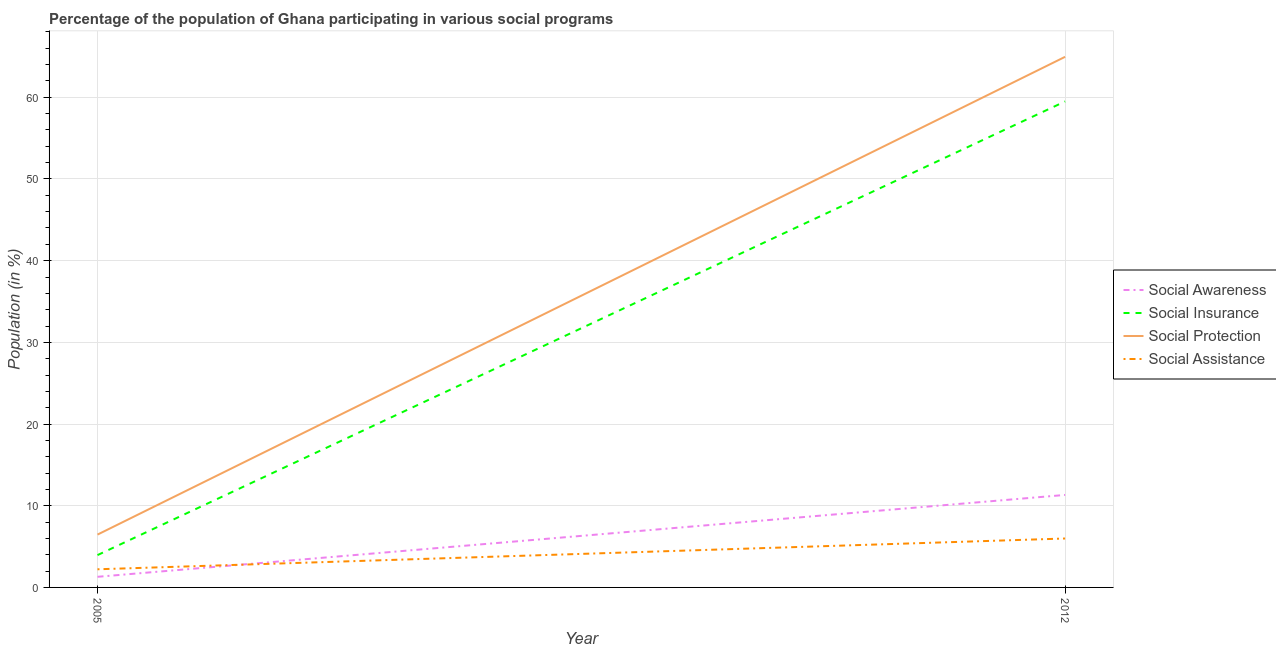How many different coloured lines are there?
Give a very brief answer. 4. Is the number of lines equal to the number of legend labels?
Offer a very short reply. Yes. What is the participation of population in social assistance programs in 2012?
Keep it short and to the point. 5.99. Across all years, what is the maximum participation of population in social protection programs?
Keep it short and to the point. 64.95. Across all years, what is the minimum participation of population in social awareness programs?
Offer a very short reply. 1.3. What is the total participation of population in social protection programs in the graph?
Offer a very short reply. 71.42. What is the difference between the participation of population in social assistance programs in 2005 and that in 2012?
Offer a very short reply. -3.77. What is the difference between the participation of population in social insurance programs in 2012 and the participation of population in social assistance programs in 2005?
Your response must be concise. 57.27. What is the average participation of population in social assistance programs per year?
Keep it short and to the point. 4.1. In the year 2005, what is the difference between the participation of population in social insurance programs and participation of population in social awareness programs?
Ensure brevity in your answer.  2.66. What is the ratio of the participation of population in social awareness programs in 2005 to that in 2012?
Provide a short and direct response. 0.11. Is the participation of population in social insurance programs in 2005 less than that in 2012?
Make the answer very short. Yes. Does the participation of population in social insurance programs monotonically increase over the years?
Ensure brevity in your answer.  Yes. What is the difference between two consecutive major ticks on the Y-axis?
Keep it short and to the point. 10. Does the graph contain any zero values?
Provide a short and direct response. No. Where does the legend appear in the graph?
Offer a very short reply. Center right. How are the legend labels stacked?
Ensure brevity in your answer.  Vertical. What is the title of the graph?
Your answer should be compact. Percentage of the population of Ghana participating in various social programs . Does "Austria" appear as one of the legend labels in the graph?
Ensure brevity in your answer.  No. What is the label or title of the Y-axis?
Keep it short and to the point. Population (in %). What is the Population (in %) of Social Awareness in 2005?
Offer a terse response. 1.3. What is the Population (in %) of Social Insurance in 2005?
Your response must be concise. 3.96. What is the Population (in %) in Social Protection in 2005?
Your answer should be compact. 6.47. What is the Population (in %) in Social Assistance in 2005?
Your answer should be compact. 2.22. What is the Population (in %) in Social Awareness in 2012?
Offer a terse response. 11.32. What is the Population (in %) in Social Insurance in 2012?
Your answer should be compact. 59.49. What is the Population (in %) in Social Protection in 2012?
Give a very brief answer. 64.95. What is the Population (in %) in Social Assistance in 2012?
Provide a short and direct response. 5.99. Across all years, what is the maximum Population (in %) of Social Awareness?
Offer a very short reply. 11.32. Across all years, what is the maximum Population (in %) in Social Insurance?
Your response must be concise. 59.49. Across all years, what is the maximum Population (in %) of Social Protection?
Offer a terse response. 64.95. Across all years, what is the maximum Population (in %) in Social Assistance?
Offer a very short reply. 5.99. Across all years, what is the minimum Population (in %) in Social Awareness?
Provide a short and direct response. 1.3. Across all years, what is the minimum Population (in %) in Social Insurance?
Keep it short and to the point. 3.96. Across all years, what is the minimum Population (in %) of Social Protection?
Your answer should be very brief. 6.47. Across all years, what is the minimum Population (in %) in Social Assistance?
Provide a succinct answer. 2.22. What is the total Population (in %) in Social Awareness in the graph?
Offer a very short reply. 12.62. What is the total Population (in %) of Social Insurance in the graph?
Your response must be concise. 63.45. What is the total Population (in %) of Social Protection in the graph?
Your answer should be compact. 71.42. What is the total Population (in %) of Social Assistance in the graph?
Your answer should be very brief. 8.21. What is the difference between the Population (in %) in Social Awareness in 2005 and that in 2012?
Give a very brief answer. -10.02. What is the difference between the Population (in %) in Social Insurance in 2005 and that in 2012?
Make the answer very short. -55.53. What is the difference between the Population (in %) in Social Protection in 2005 and that in 2012?
Ensure brevity in your answer.  -58.48. What is the difference between the Population (in %) of Social Assistance in 2005 and that in 2012?
Give a very brief answer. -3.77. What is the difference between the Population (in %) in Social Awareness in 2005 and the Population (in %) in Social Insurance in 2012?
Your response must be concise. -58.19. What is the difference between the Population (in %) in Social Awareness in 2005 and the Population (in %) in Social Protection in 2012?
Your answer should be very brief. -63.65. What is the difference between the Population (in %) in Social Awareness in 2005 and the Population (in %) in Social Assistance in 2012?
Offer a terse response. -4.69. What is the difference between the Population (in %) of Social Insurance in 2005 and the Population (in %) of Social Protection in 2012?
Offer a terse response. -61. What is the difference between the Population (in %) of Social Insurance in 2005 and the Population (in %) of Social Assistance in 2012?
Make the answer very short. -2.03. What is the difference between the Population (in %) of Social Protection in 2005 and the Population (in %) of Social Assistance in 2012?
Offer a terse response. 0.48. What is the average Population (in %) in Social Awareness per year?
Offer a terse response. 6.31. What is the average Population (in %) in Social Insurance per year?
Your answer should be compact. 31.72. What is the average Population (in %) in Social Protection per year?
Make the answer very short. 35.71. What is the average Population (in %) of Social Assistance per year?
Your answer should be very brief. 4.1. In the year 2005, what is the difference between the Population (in %) in Social Awareness and Population (in %) in Social Insurance?
Make the answer very short. -2.66. In the year 2005, what is the difference between the Population (in %) of Social Awareness and Population (in %) of Social Protection?
Provide a succinct answer. -5.17. In the year 2005, what is the difference between the Population (in %) of Social Awareness and Population (in %) of Social Assistance?
Offer a very short reply. -0.92. In the year 2005, what is the difference between the Population (in %) of Social Insurance and Population (in %) of Social Protection?
Provide a short and direct response. -2.51. In the year 2005, what is the difference between the Population (in %) in Social Insurance and Population (in %) in Social Assistance?
Give a very brief answer. 1.74. In the year 2005, what is the difference between the Population (in %) in Social Protection and Population (in %) in Social Assistance?
Your answer should be compact. 4.25. In the year 2012, what is the difference between the Population (in %) of Social Awareness and Population (in %) of Social Insurance?
Your answer should be compact. -48.17. In the year 2012, what is the difference between the Population (in %) in Social Awareness and Population (in %) in Social Protection?
Ensure brevity in your answer.  -53.63. In the year 2012, what is the difference between the Population (in %) in Social Awareness and Population (in %) in Social Assistance?
Provide a succinct answer. 5.33. In the year 2012, what is the difference between the Population (in %) in Social Insurance and Population (in %) in Social Protection?
Provide a short and direct response. -5.46. In the year 2012, what is the difference between the Population (in %) in Social Insurance and Population (in %) in Social Assistance?
Provide a short and direct response. 53.5. In the year 2012, what is the difference between the Population (in %) of Social Protection and Population (in %) of Social Assistance?
Provide a short and direct response. 58.96. What is the ratio of the Population (in %) in Social Awareness in 2005 to that in 2012?
Give a very brief answer. 0.11. What is the ratio of the Population (in %) in Social Insurance in 2005 to that in 2012?
Ensure brevity in your answer.  0.07. What is the ratio of the Population (in %) of Social Protection in 2005 to that in 2012?
Your answer should be very brief. 0.1. What is the ratio of the Population (in %) of Social Assistance in 2005 to that in 2012?
Make the answer very short. 0.37. What is the difference between the highest and the second highest Population (in %) of Social Awareness?
Offer a terse response. 10.02. What is the difference between the highest and the second highest Population (in %) of Social Insurance?
Provide a succinct answer. 55.53. What is the difference between the highest and the second highest Population (in %) in Social Protection?
Your response must be concise. 58.48. What is the difference between the highest and the second highest Population (in %) of Social Assistance?
Make the answer very short. 3.77. What is the difference between the highest and the lowest Population (in %) of Social Awareness?
Give a very brief answer. 10.02. What is the difference between the highest and the lowest Population (in %) in Social Insurance?
Offer a very short reply. 55.53. What is the difference between the highest and the lowest Population (in %) of Social Protection?
Your answer should be compact. 58.48. What is the difference between the highest and the lowest Population (in %) of Social Assistance?
Provide a short and direct response. 3.77. 